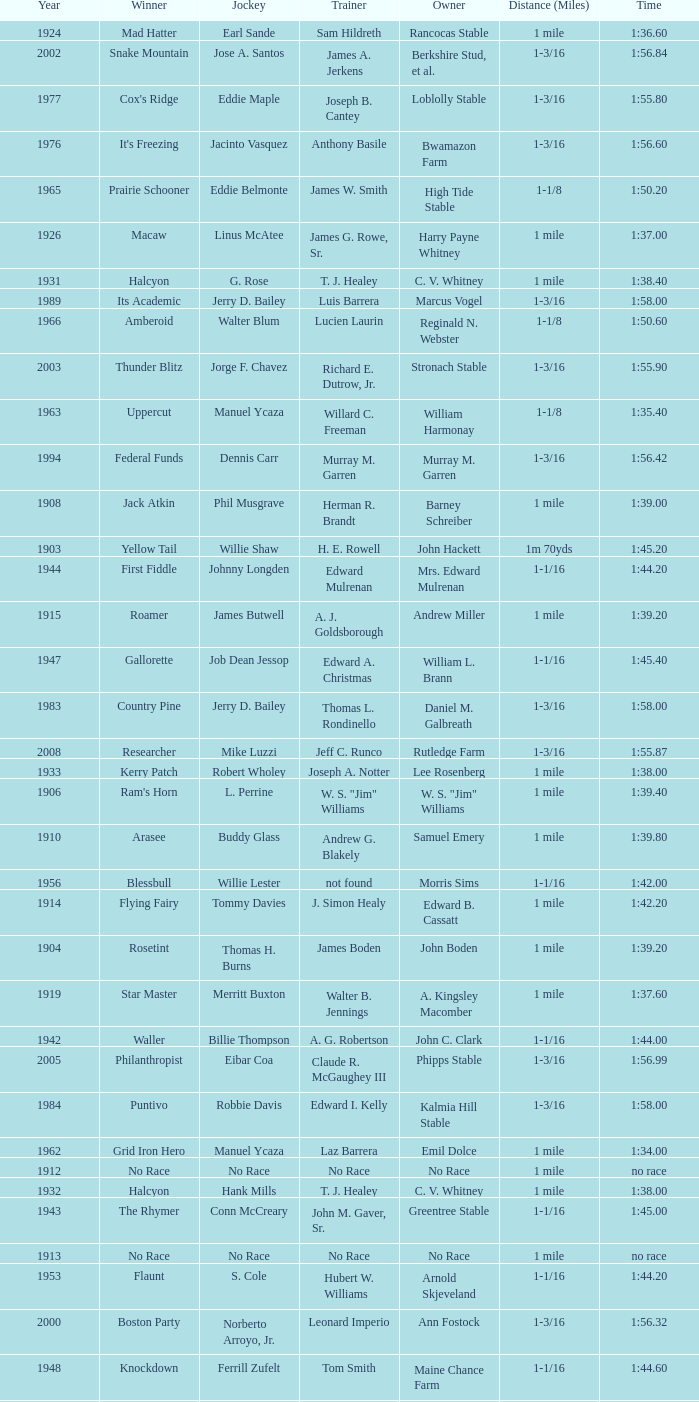What was the winning time for the winning horse, Kentucky ii? 1:38.80. 